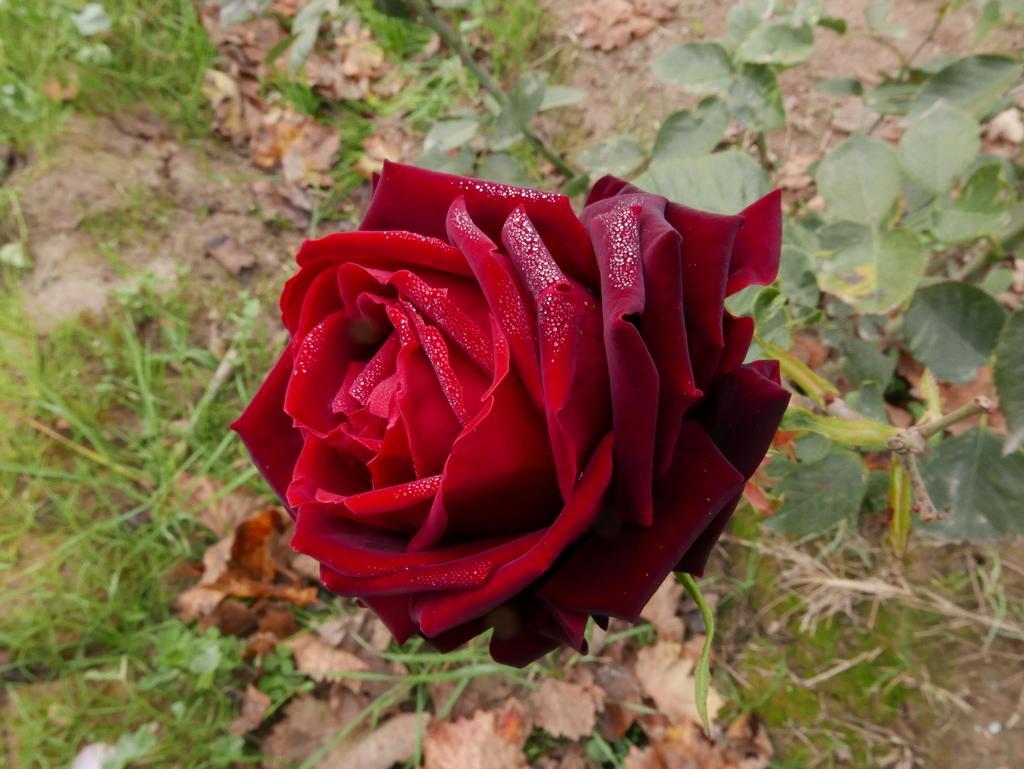In one or two sentences, can you explain what this image depicts? In this image I can see the flower and the flower is in red color. Background I can see few plants in green color. 